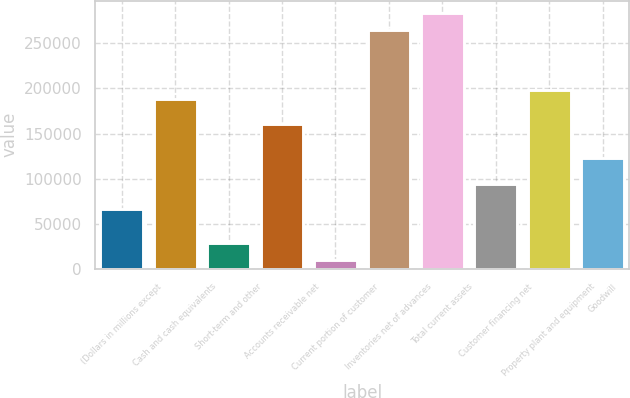<chart> <loc_0><loc_0><loc_500><loc_500><bar_chart><fcel>(Dollars in millions except<fcel>Cash and cash equivalents<fcel>Short-term and other<fcel>Accounts receivable net<fcel>Current portion of customer<fcel>Inventories net of advances<fcel>Total current assets<fcel>Customer financing net<fcel>Property plant and equipment<fcel>Goodwill<nl><fcel>66104.2<fcel>188754<fcel>28365.8<fcel>160450<fcel>9496.6<fcel>264231<fcel>283100<fcel>94408<fcel>198189<fcel>122712<nl></chart> 